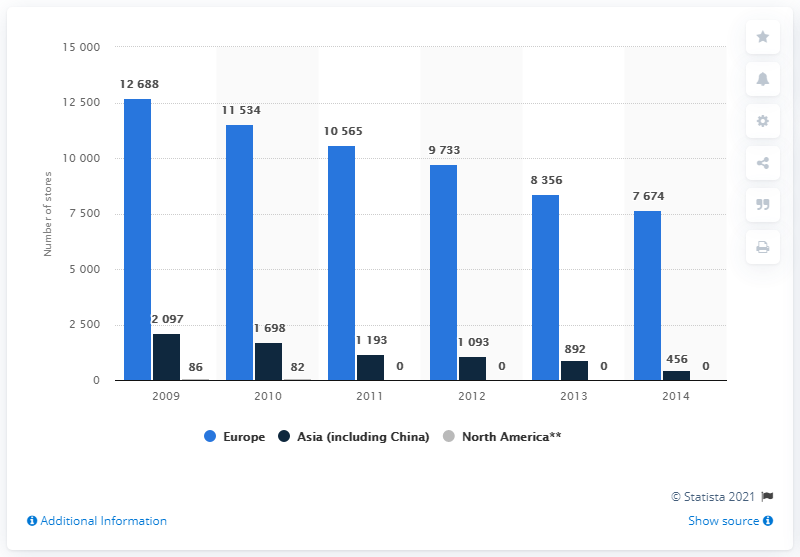Give some essential details in this illustration. In 2011, there were 10,565 ESPRIT point of sale locations in Europe. 